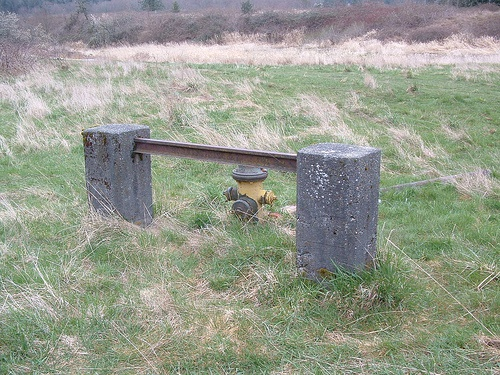Describe the objects in this image and their specific colors. I can see a fire hydrant in gray, darkgray, and tan tones in this image. 